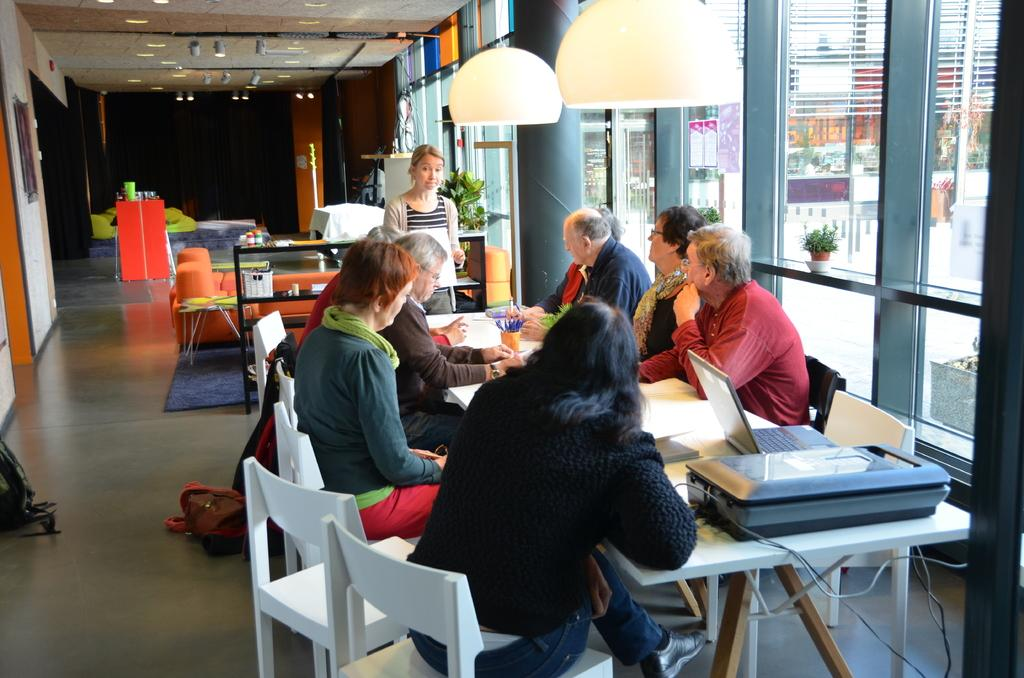What is happening in the image? There are people sitting around a table. What objects can be seen on the table? There is a laptop and a printer on the table. What type of lighting is present in the image? There are lights from the top. Can you see a spot on the laptop in the image? There is no mention of a spot on the laptop in the provided facts, so it cannot be determined from the image. 